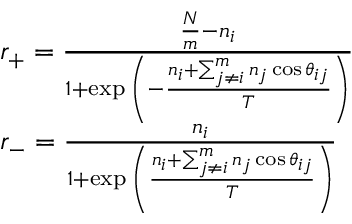Convert formula to latex. <formula><loc_0><loc_0><loc_500><loc_500>\begin{array} { l } { r _ { + } = \frac { \frac { N } { m } - n _ { i } } { 1 + \exp { \left ( - \frac { n _ { i } + \sum _ { j \neq i } ^ { m } n _ { j } \cos { \theta _ { i j } } } { T } \right ) } } } \\ { r _ { - } = \frac { n _ { i } } { 1 + \exp { \left ( { \frac { n _ { i } + \sum _ { j \neq i } ^ { m } n _ { j } \cos { \theta _ { i j } } } { T } } \right ) } } } \end{array}</formula> 